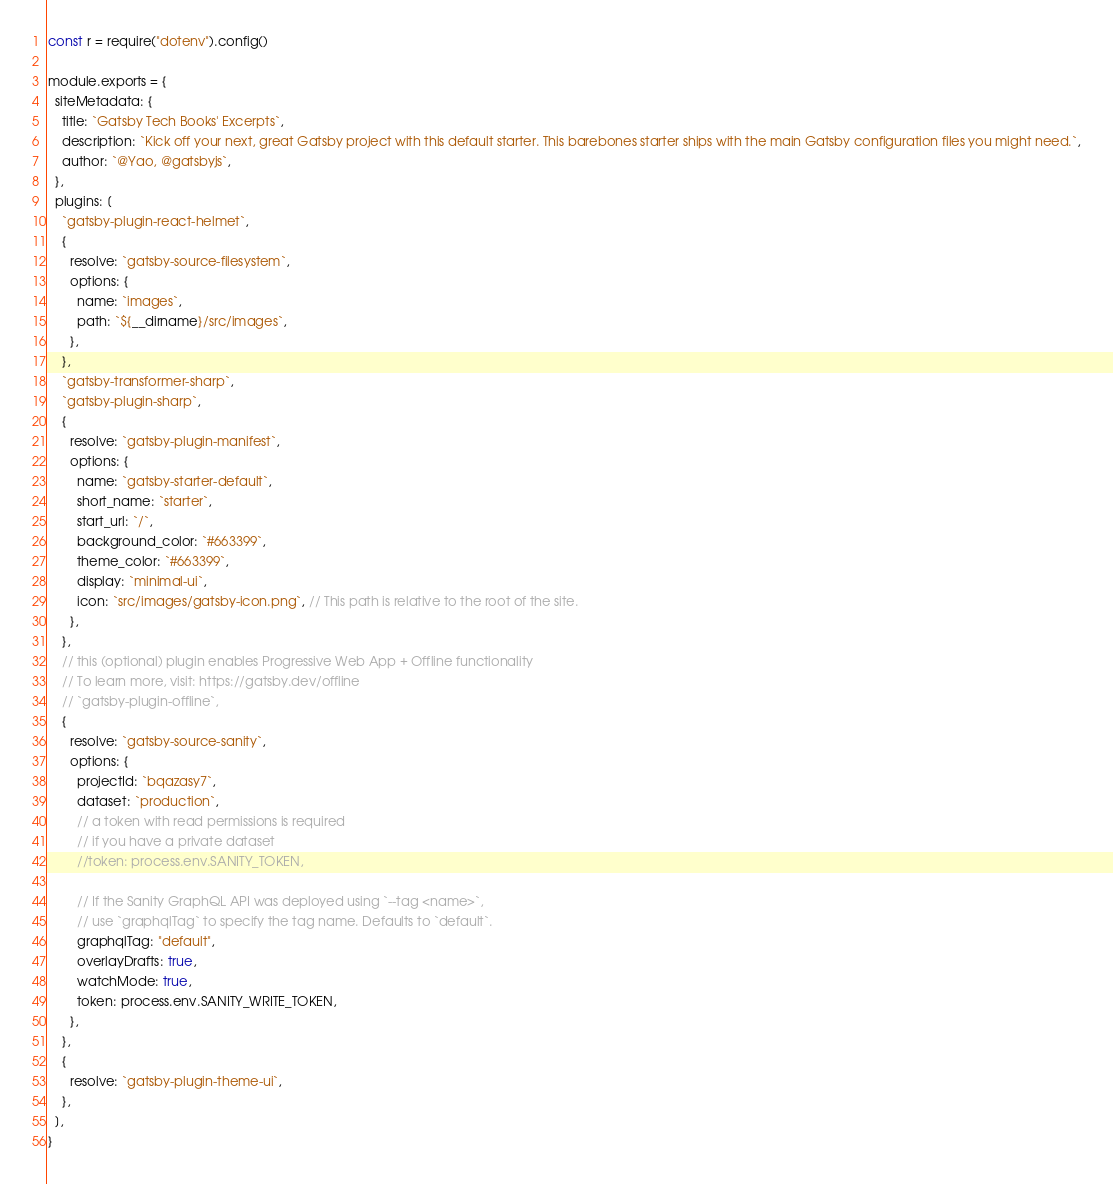Convert code to text. <code><loc_0><loc_0><loc_500><loc_500><_JavaScript_>const r = require("dotenv").config()

module.exports = {
  siteMetadata: {
    title: `Gatsby Tech Books' Excerpts`,
    description: `Kick off your next, great Gatsby project with this default starter. This barebones starter ships with the main Gatsby configuration files you might need.`,
    author: `@Yao, @gatsbyjs`,
  },
  plugins: [
    `gatsby-plugin-react-helmet`,
    {
      resolve: `gatsby-source-filesystem`,
      options: {
        name: `images`,
        path: `${__dirname}/src/images`,
      },
    },
    `gatsby-transformer-sharp`,
    `gatsby-plugin-sharp`,
    {
      resolve: `gatsby-plugin-manifest`,
      options: {
        name: `gatsby-starter-default`,
        short_name: `starter`,
        start_url: `/`,
        background_color: `#663399`,
        theme_color: `#663399`,
        display: `minimal-ui`,
        icon: `src/images/gatsby-icon.png`, // This path is relative to the root of the site.
      },
    },
    // this (optional) plugin enables Progressive Web App + Offline functionality
    // To learn more, visit: https://gatsby.dev/offline
    // `gatsby-plugin-offline`,
    {
      resolve: `gatsby-source-sanity`,
      options: {
        projectId: `bqazasy7`,
        dataset: `production`,
        // a token with read permissions is required
        // if you have a private dataset
        //token: process.env.SANITY_TOKEN,

        // If the Sanity GraphQL API was deployed using `--tag <name>`,
        // use `graphqlTag` to specify the tag name. Defaults to `default`.
        graphqlTag: "default",
        overlayDrafts: true,
        watchMode: true,
        token: process.env.SANITY_WRITE_TOKEN,
      },
    },
    {
      resolve: `gatsby-plugin-theme-ui`,
    },
  ],
}
</code> 